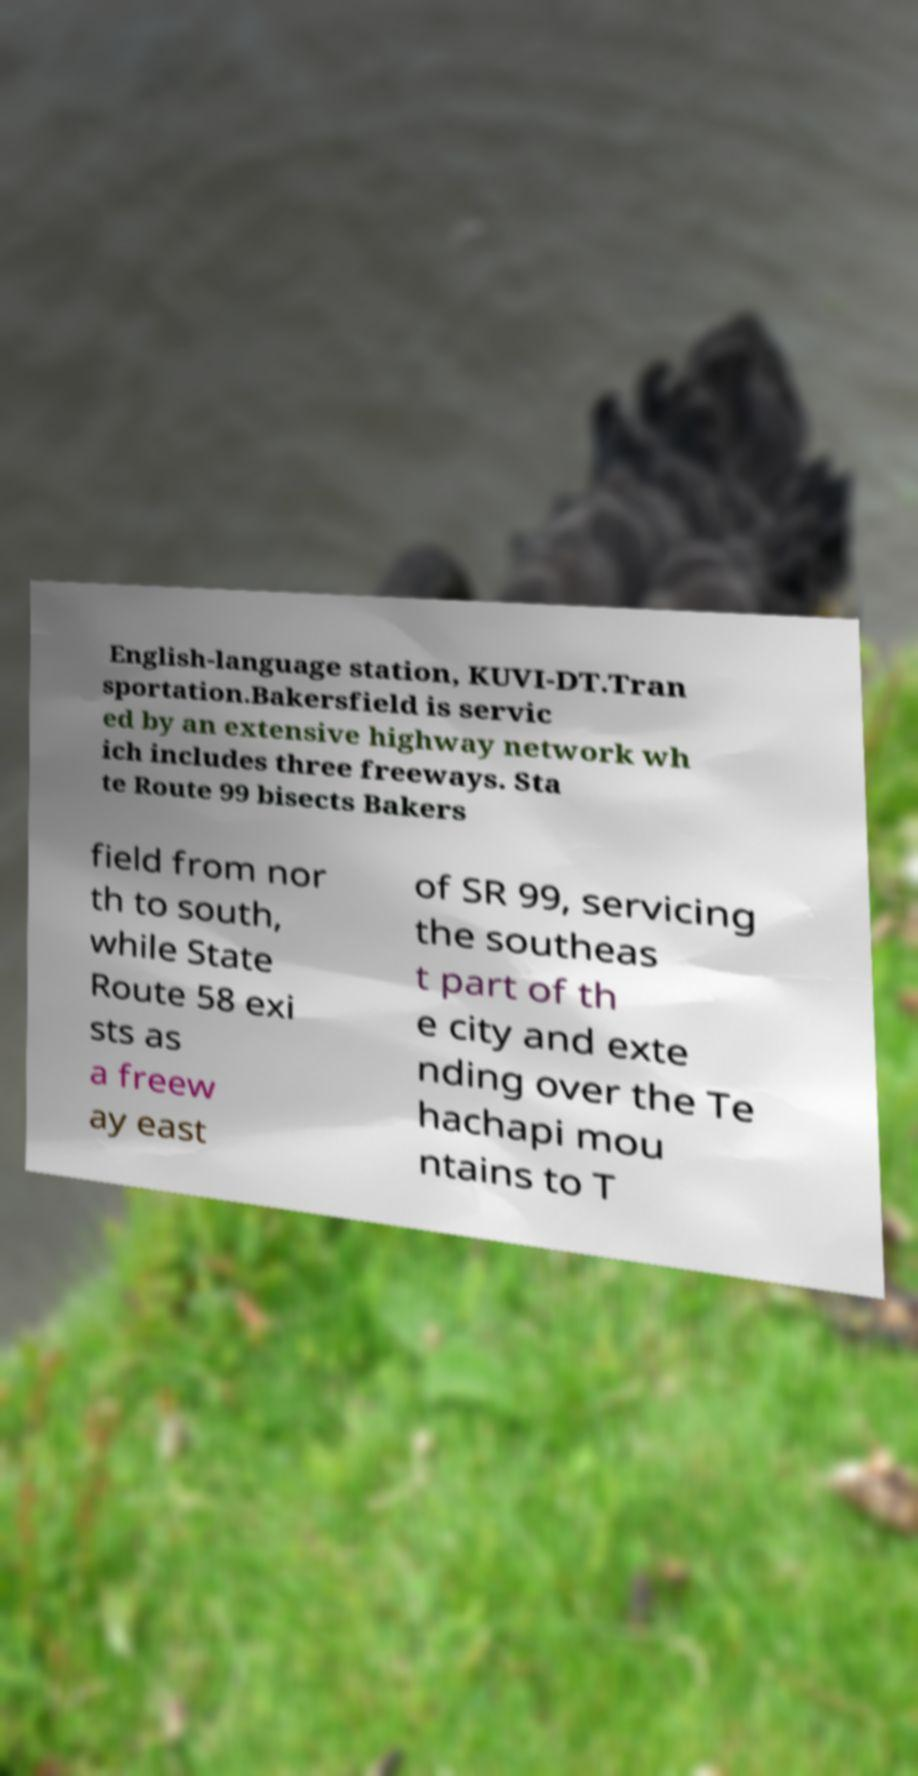Please identify and transcribe the text found in this image. English-language station, KUVI-DT.Tran sportation.Bakersfield is servic ed by an extensive highway network wh ich includes three freeways. Sta te Route 99 bisects Bakers field from nor th to south, while State Route 58 exi sts as a freew ay east of SR 99, servicing the southeas t part of th e city and exte nding over the Te hachapi mou ntains to T 